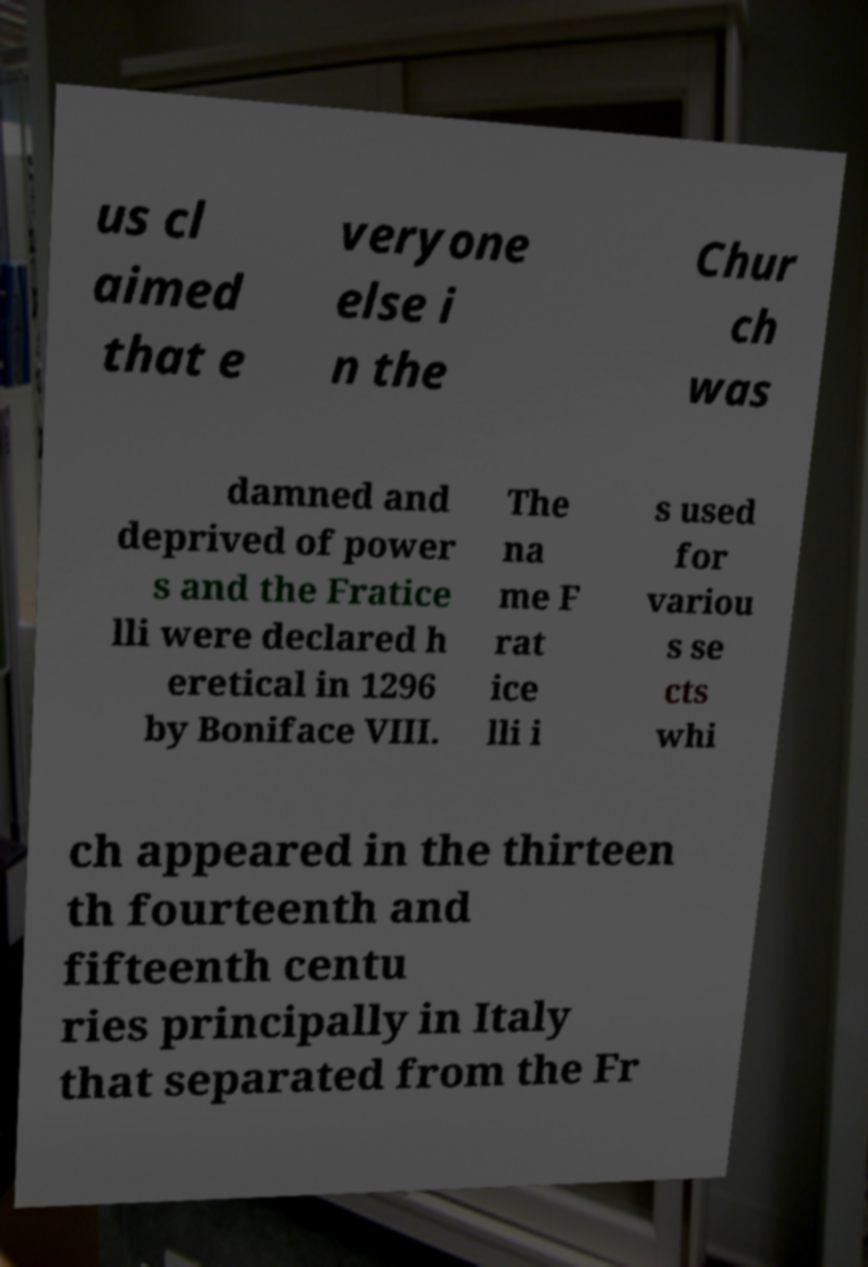Could you assist in decoding the text presented in this image and type it out clearly? us cl aimed that e veryone else i n the Chur ch was damned and deprived of power s and the Fratice lli were declared h eretical in 1296 by Boniface VIII. The na me F rat ice lli i s used for variou s se cts whi ch appeared in the thirteen th fourteenth and fifteenth centu ries principally in Italy that separated from the Fr 